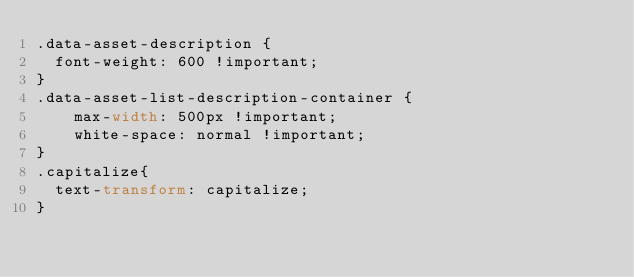<code> <loc_0><loc_0><loc_500><loc_500><_CSS_>.data-asset-description {
  font-weight: 600 !important;
}
.data-asset-list-description-container {
    max-width: 500px !important;
    white-space: normal !important;
}
.capitalize{
  text-transform: capitalize;
}</code> 